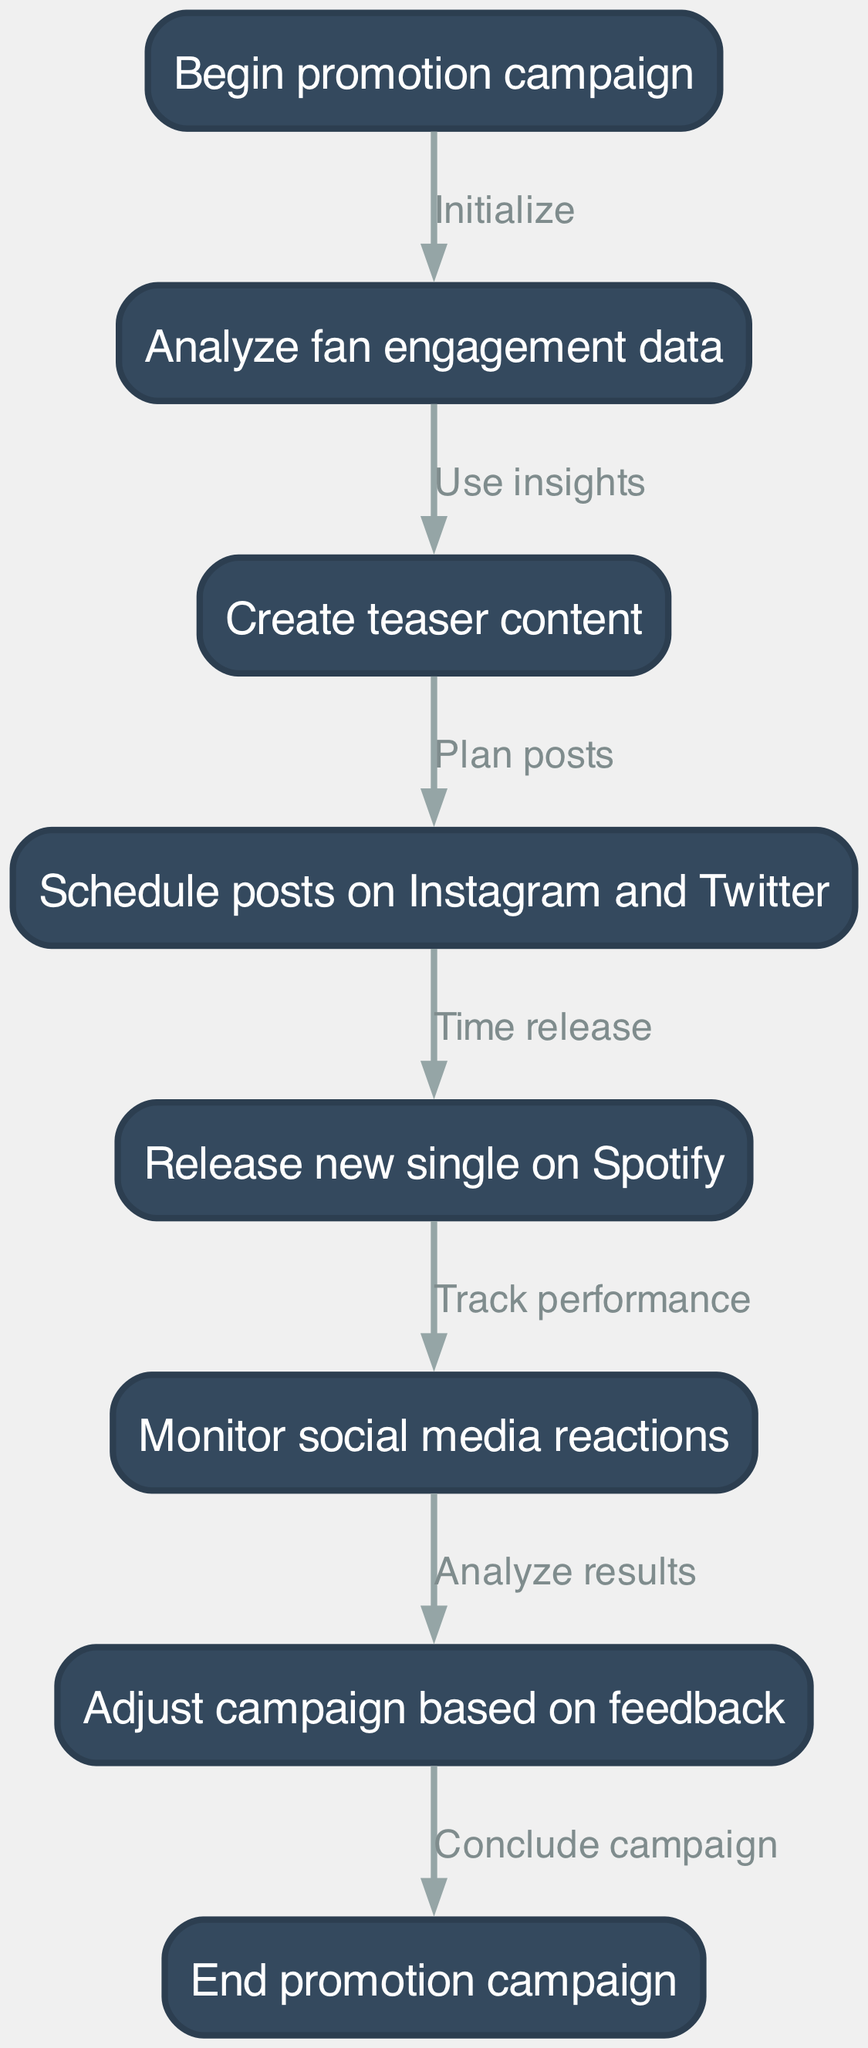What is the first action in the flowchart? The flowchart begins with the node labeled "Begin promotion campaign," which is the starting point of the process.
Answer: Begin promotion campaign How many nodes are in the diagram? By counting the nodes listed in the data provided, there are a total of eight distinct actions or states within the flowchart.
Answer: Eight Which node follows the "Analyze fan engagement data"? After "Analyze fan engagement data," the next step in the flowchart, as indicated by the directed edge, is to "Create teaser content."
Answer: Create teaser content What is the last action before concluding the campaign? The last action prior to ending the campaign is "Adjust campaign based on feedback," which is necessary to finalize the process.
Answer: Adjust campaign based on feedback What is the connection between "Schedule posts on Instagram and Twitter" and "Release new single on Spotify"? The connection is that "Schedule posts on Instagram and Twitter" leads directly to the next action of "Release new single on Spotify," indicating that the posts are timed with the release event.
Answer: Release new single on Spotify How does the campaign progress from "Monitor social media reactions"? After monitoring reactions, the flowchart specifies to "Adjust campaign based on feedback," showing that the results influence the next steps in the promotional strategy.
Answer: Adjust campaign based on feedback What do you do after "Release new single on Spotify"? Following the release, the campaign's next step involves "Monitor social media reactions," highlighting the importance of tracking audience response after the launch.
Answer: Monitor social media reactions How many edges connect the nodes in the flowchart? The number of edges can be calculated by counting the directed connections; there are a total of seven edges linking the actions together in the process.
Answer: Seven 